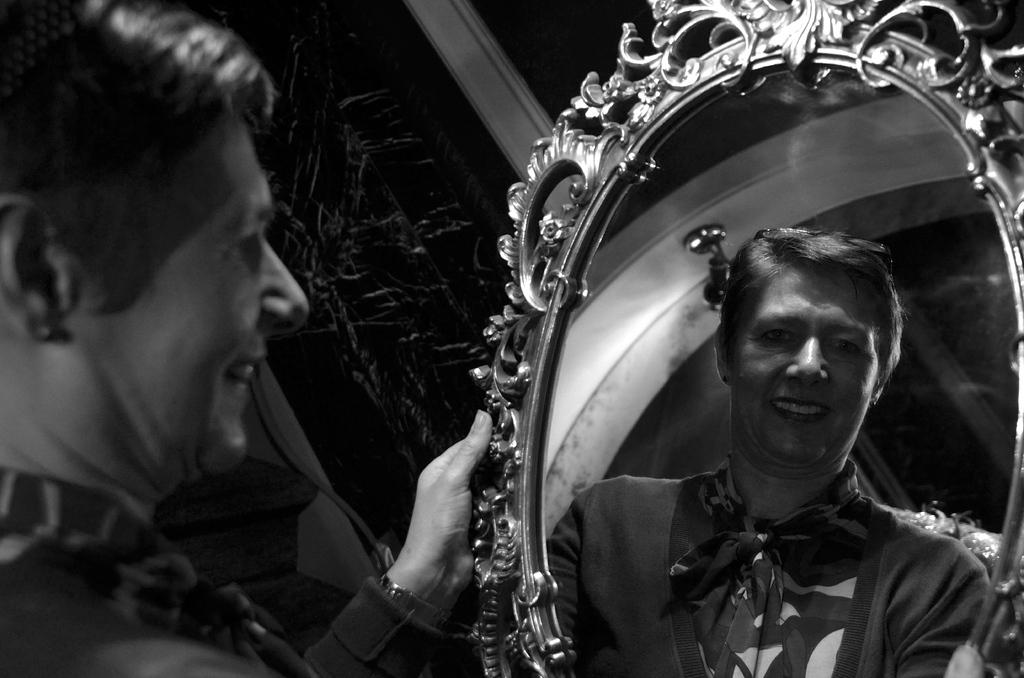What is the color scheme of the image? The image is black and white. Who is present in the image? There is a woman in the image. What is the woman holding in the image? The woman is holding a mirror. What can be seen in the mirror? The reflected image of the woman is visible in the mirror. Where is the giraffe standing in the image? There is no giraffe present in the image. Is the woman performing on a stage in the image? The image does not show a stage, and there is no indication that the woman is performing. 